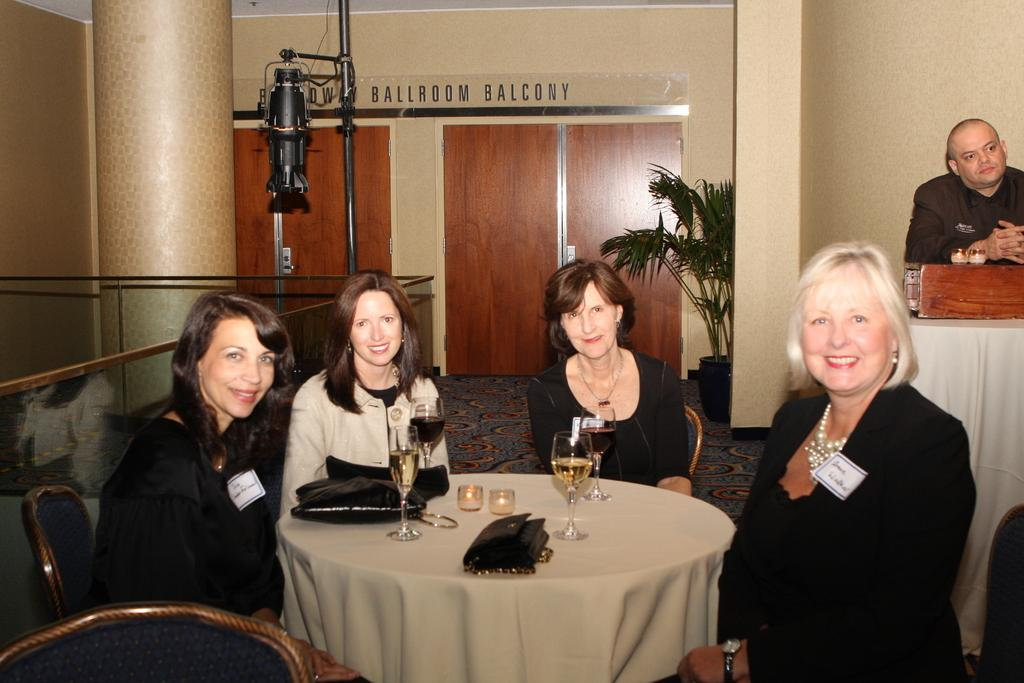What is the main subject of the image? The main subject of the image is a group of men. What are the men doing in the image? The men are sitting on chairs in the image. Where are the chairs located in relation to the table? The chairs are in front of a table in the image. What can be seen on the table besides the chairs? There are wine glasses and other objects on the table in the image. What type of anger is being expressed by the men in the image? There is no indication of anger in the image; the men are simply sitting on chairs. What memories are the men discussing in the image? There is no information about the men's conversation in the image, so it cannot be determined what memories they might be discussing. 